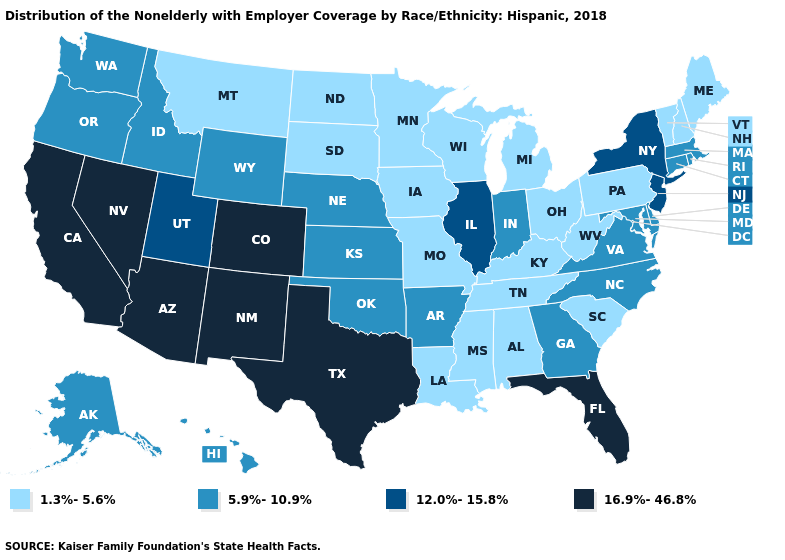What is the value of Maine?
Be succinct. 1.3%-5.6%. Which states have the lowest value in the Northeast?
Concise answer only. Maine, New Hampshire, Pennsylvania, Vermont. Which states have the lowest value in the USA?
Keep it brief. Alabama, Iowa, Kentucky, Louisiana, Maine, Michigan, Minnesota, Mississippi, Missouri, Montana, New Hampshire, North Dakota, Ohio, Pennsylvania, South Carolina, South Dakota, Tennessee, Vermont, West Virginia, Wisconsin. What is the highest value in the USA?
Short answer required. 16.9%-46.8%. Is the legend a continuous bar?
Write a very short answer. No. Name the states that have a value in the range 12.0%-15.8%?
Answer briefly. Illinois, New Jersey, New York, Utah. Does West Virginia have a higher value than Colorado?
Answer briefly. No. What is the highest value in states that border Delaware?
Quick response, please. 12.0%-15.8%. What is the highest value in the USA?
Concise answer only. 16.9%-46.8%. Name the states that have a value in the range 12.0%-15.8%?
Short answer required. Illinois, New Jersey, New York, Utah. What is the value of Arkansas?
Be succinct. 5.9%-10.9%. Name the states that have a value in the range 5.9%-10.9%?
Short answer required. Alaska, Arkansas, Connecticut, Delaware, Georgia, Hawaii, Idaho, Indiana, Kansas, Maryland, Massachusetts, Nebraska, North Carolina, Oklahoma, Oregon, Rhode Island, Virginia, Washington, Wyoming. Does North Dakota have the same value as Texas?
Write a very short answer. No. What is the lowest value in the Northeast?
Be succinct. 1.3%-5.6%. 